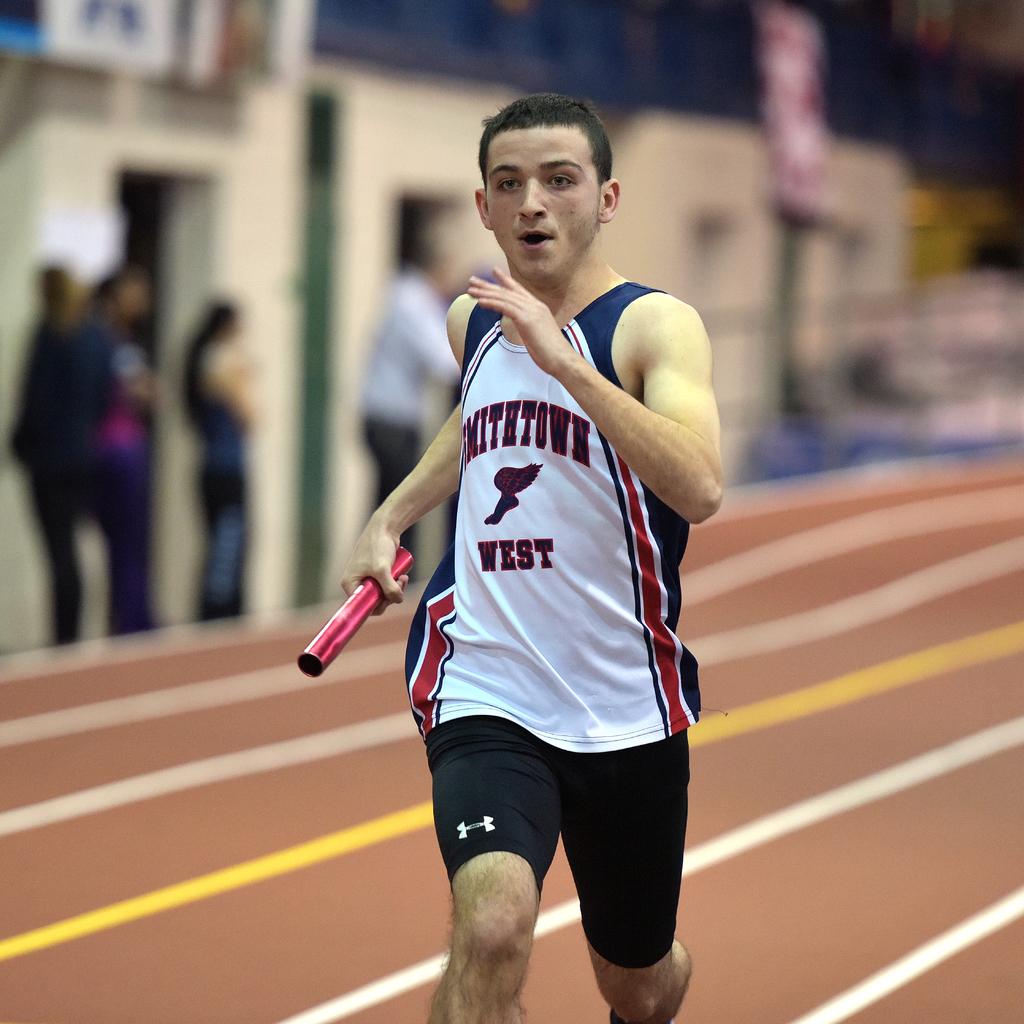What school does this track and field athlete attend?
Your answer should be compact. Smithtown west. 